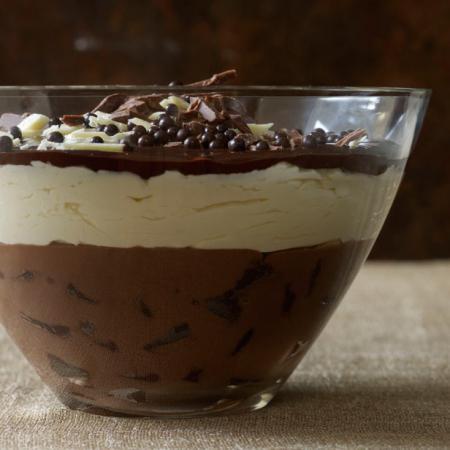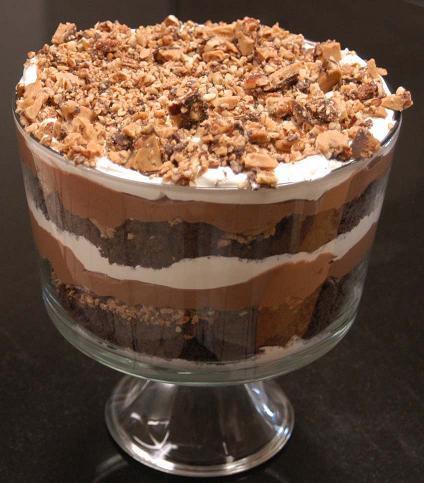The first image is the image on the left, the second image is the image on the right. For the images shown, is this caption "Two large layered desserts made with chocolate and creamy layers and topped with a garnish are in clear glass bowls, at least one of them footed." true? Answer yes or no. Yes. The first image is the image on the left, the second image is the image on the right. Considering the images on both sides, is "A dessert with a thick bottom chocolate layer and chocolate garnish on top is served in a non-footed glass." valid? Answer yes or no. Yes. 